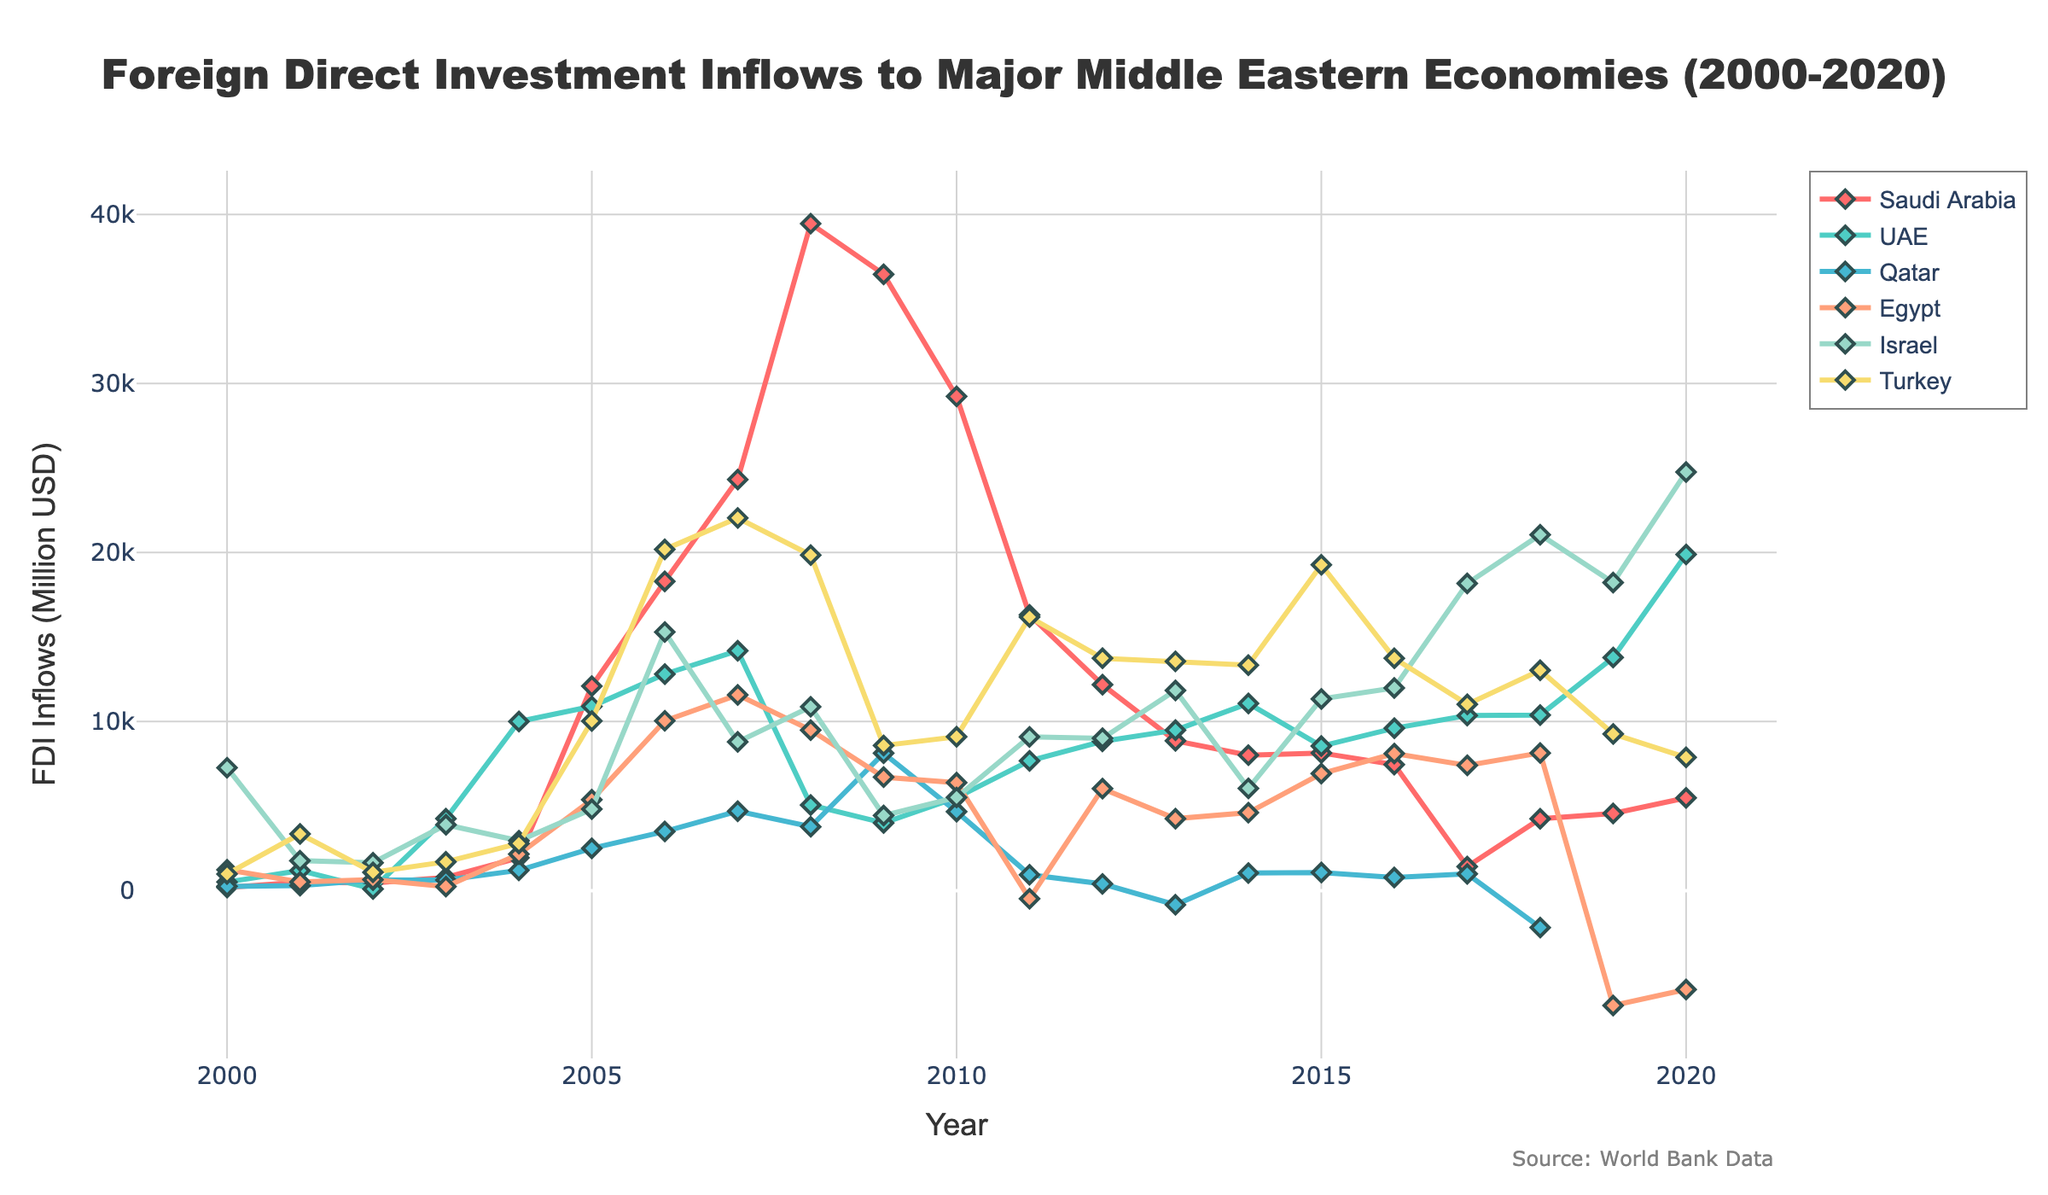What year did Saudi Arabia have the highest FDI inflows? By looking at the plot, we can see that Saudi Arabia's FDI inflows peaked in one particular year. Identify the year with the highest value for the Saudi Arabia line.
Answer: 2008 Which country had the most consistent increase in FDI inflows between 2000 and 2020? To determine which country had the most consistent increase, compare the trends in the lines for all the countries and see which one shows the steadiest upward trajectory over the 20-year period.
Answer: UAE In which year did Turkey's FDI inflow exceed that of Israel's? Compare the lines representing Turkey and Israel and find the year where Turkey's line first surpasses Israel's line.
Answer: 2005 What is the total FDI inflow for Qatar over the last decade (2011-2020)? Sum the FDI inflows for Qatar from 2011 to 2020 by referring to the values at the respective years. Since values for 2018 and 2019 are missing, consider only the available data.
Answer: 6204 (estimated) Which two countries had negative FDI inflows in any year, and in which years did this occur? Identify the countries where the line dips below zero and note the specific years.
Answer: Egypt (2011, 2019, 2020), Qatar (2018, 2019) How did Egypt's FDI inflows in 2010 compare to its inflows in 2000? Compare the Y-axis values of Egypt's FDI inflows for 2010 and 2000.
Answer: 2010 was lower than 2000 Which country saw the steepest decline in FDI inflows between any two consecutive years? Look for the line with the sharpest drop between any two consecutive years and note the country and years.
Answer: Saudi Arabia (2008-2009) What is the average FDI inflow for Israel from 2000 to 2020? Sum all the FDI inflows for Israel from 2000 to 2020 and divide by the number of years.
Answer: 10394 What is the difference in FDI inflows between Turkey and Saudi Arabia in 2006? Subtract Saudi Arabia's FDI inflow from Turkey's FDI inflow for the year 2006.
Answer: 1888 